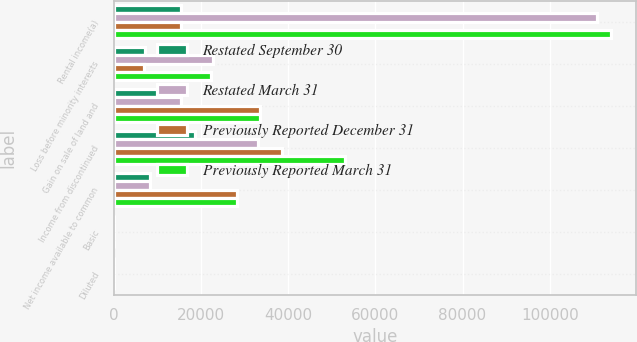<chart> <loc_0><loc_0><loc_500><loc_500><stacked_bar_chart><ecel><fcel>Rental income(a)<fcel>Loss before minority interests<fcel>Gain on sale of land and<fcel>Income from discontinued<fcel>Net income available to common<fcel>Basic<fcel>Diluted<nl><fcel>Restated September 30<fcel>15347<fcel>7193<fcel>15347<fcel>18550<fcel>8165<fcel>0.06<fcel>0.06<nl><fcel>Restated March 31<fcel>110954<fcel>22707<fcel>15347<fcel>33123<fcel>8165<fcel>0.06<fcel>0.06<nl><fcel>Previously Reported December 31<fcel>15347<fcel>6986<fcel>33482<fcel>38545<fcel>28342<fcel>0.21<fcel>0.21<nl><fcel>Previously Reported March 31<fcel>114025<fcel>22276<fcel>33482<fcel>52923<fcel>28342<fcel>0.21<fcel>0.21<nl></chart> 